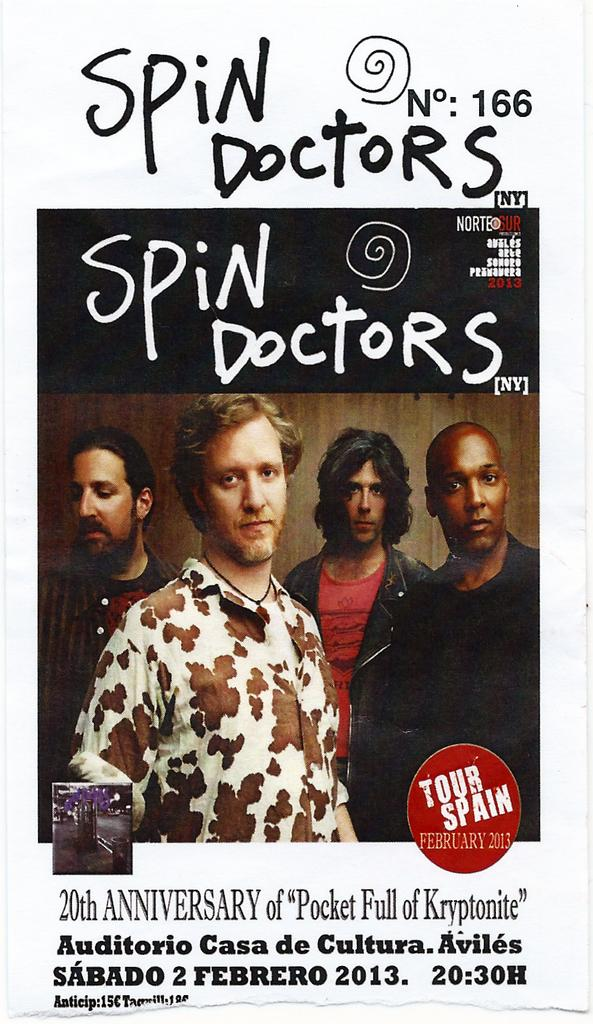<image>
Give a short and clear explanation of the subsequent image. a poster for the Spin Doctors 20th Anniversary 